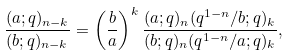<formula> <loc_0><loc_0><loc_500><loc_500>\frac { ( a ; q ) _ { n - k } } { ( b ; q ) _ { n - k } } = \left ( \frac { b } { a } \right ) ^ { k } \frac { ( a ; q ) _ { n } ( q ^ { 1 - n } / b ; q ) _ { k } } { ( b ; q ) _ { n } ( q ^ { 1 - n } / a ; q ) _ { k } } ,</formula> 